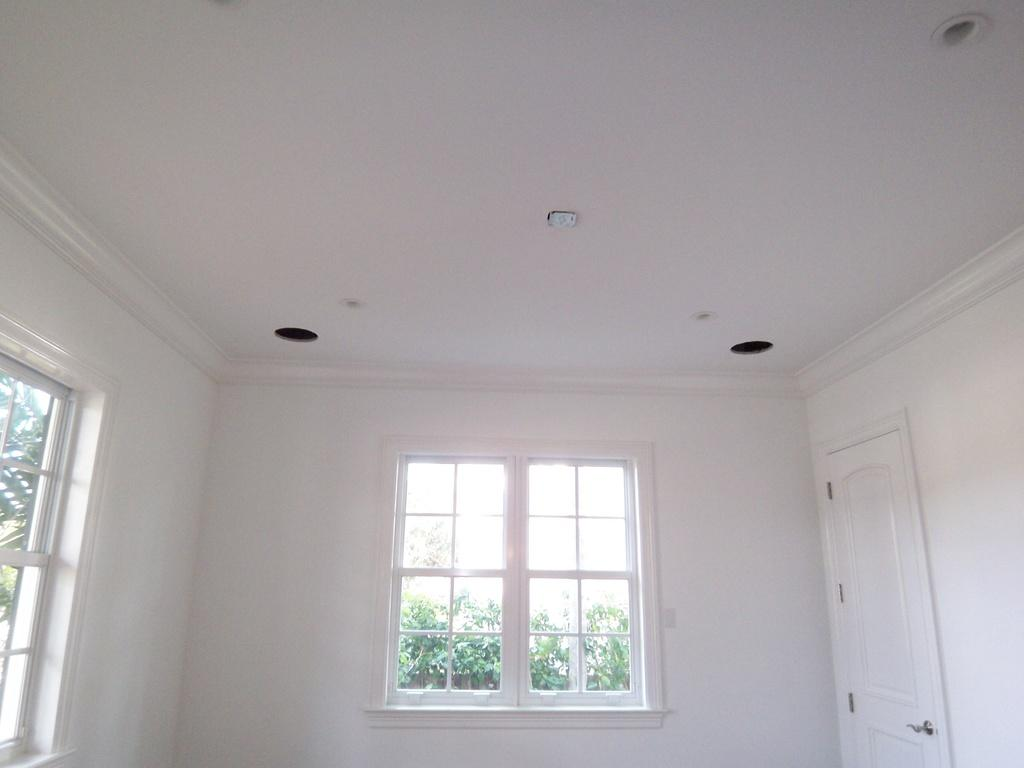What type of openings can be seen in the image? There are windows in the image. Where is the door located in the image? The door is on the right side of the image. What color is the wall in the image? The wall is white in color. What can be seen through the windows in the image? There are trees visible behind the windows. Where is the seat located in the image? There is no seat present in the image. What type of cheese can be seen growing on the wall in the image? There is no cheese present in the image, and walls do not grow anything. --- Facts: 1. There is a car in the image. 2. The car is red. 3. The car has four wheels. 4. There are people in the car. 5. The car is parked on the street. Absurd Topics: fish, mountain, dance Conversation: What type of vehicle is in the image? There is a car in the image. What color is the car? The car is red. How many wheels does the car have? The car has four wheels. Who is inside the car? There are people in the car. Where is the car located in the image? The car is parked on the street. Reasoning: Let's think step by step in order to produce the conversation. We start by identifying the main subject in the image, which is the car. Then, we expand the conversation to include other details about the car, such as its color, number of wheels, and occupants. Finally, we describe the car's location in the image, which is parked on the street. Each question is designed to elicit a specific detail about the image that is known from the provided facts. Absurd Question/Answer: Can you see any fish swimming in the car in the image? There are no fish present in the image, and fish cannot swim in cars. What type of dance is being performed on top of the mountain in the image? There is no mountain or dance present in the image. 